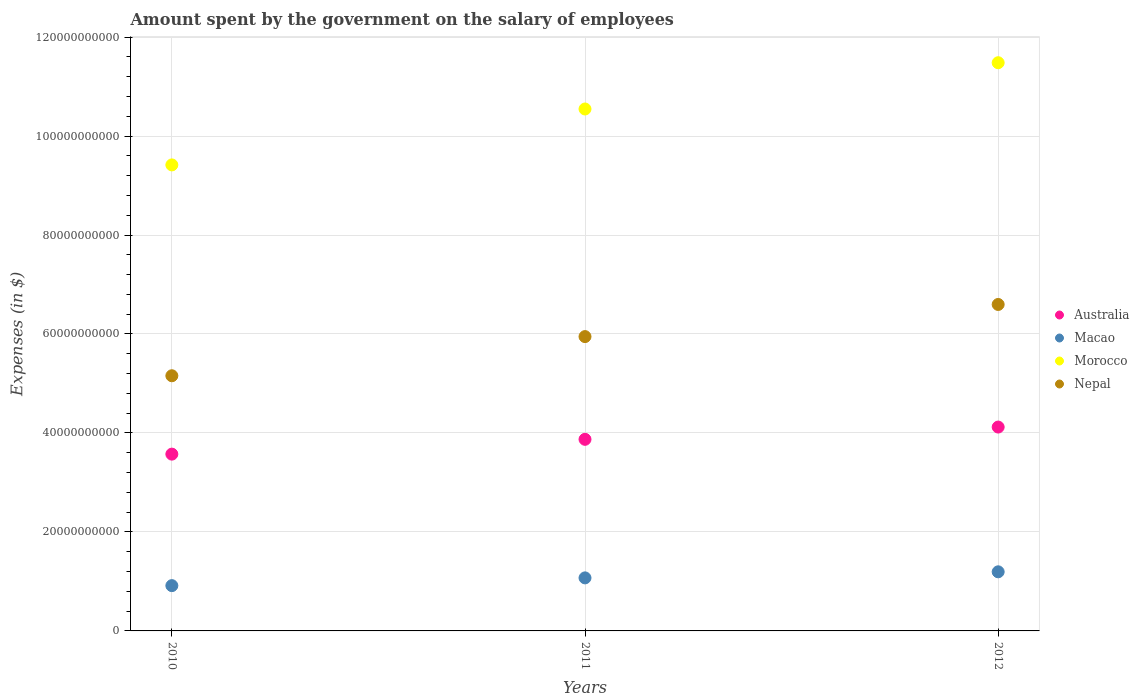What is the amount spent on the salary of employees by the government in Australia in 2011?
Give a very brief answer. 3.87e+1. Across all years, what is the maximum amount spent on the salary of employees by the government in Morocco?
Provide a succinct answer. 1.15e+11. Across all years, what is the minimum amount spent on the salary of employees by the government in Australia?
Provide a succinct answer. 3.57e+1. In which year was the amount spent on the salary of employees by the government in Macao maximum?
Your answer should be compact. 2012. In which year was the amount spent on the salary of employees by the government in Nepal minimum?
Offer a terse response. 2010. What is the total amount spent on the salary of employees by the government in Australia in the graph?
Provide a succinct answer. 1.16e+11. What is the difference between the amount spent on the salary of employees by the government in Australia in 2010 and that in 2012?
Your answer should be compact. -5.47e+09. What is the difference between the amount spent on the salary of employees by the government in Macao in 2011 and the amount spent on the salary of employees by the government in Australia in 2012?
Offer a terse response. -3.05e+1. What is the average amount spent on the salary of employees by the government in Australia per year?
Your answer should be compact. 3.85e+1. In the year 2011, what is the difference between the amount spent on the salary of employees by the government in Morocco and amount spent on the salary of employees by the government in Australia?
Offer a terse response. 6.67e+1. What is the ratio of the amount spent on the salary of employees by the government in Macao in 2010 to that in 2011?
Your response must be concise. 0.85. Is the amount spent on the salary of employees by the government in Macao in 2010 less than that in 2011?
Give a very brief answer. Yes. Is the difference between the amount spent on the salary of employees by the government in Morocco in 2010 and 2011 greater than the difference between the amount spent on the salary of employees by the government in Australia in 2010 and 2011?
Make the answer very short. No. What is the difference between the highest and the second highest amount spent on the salary of employees by the government in Australia?
Give a very brief answer. 2.48e+09. What is the difference between the highest and the lowest amount spent on the salary of employees by the government in Macao?
Your response must be concise. 2.79e+09. In how many years, is the amount spent on the salary of employees by the government in Nepal greater than the average amount spent on the salary of employees by the government in Nepal taken over all years?
Ensure brevity in your answer.  2. Is the sum of the amount spent on the salary of employees by the government in Morocco in 2011 and 2012 greater than the maximum amount spent on the salary of employees by the government in Australia across all years?
Provide a short and direct response. Yes. Is it the case that in every year, the sum of the amount spent on the salary of employees by the government in Nepal and amount spent on the salary of employees by the government in Australia  is greater than the amount spent on the salary of employees by the government in Macao?
Offer a terse response. Yes. Is the amount spent on the salary of employees by the government in Nepal strictly less than the amount spent on the salary of employees by the government in Macao over the years?
Provide a succinct answer. No. How many dotlines are there?
Provide a succinct answer. 4. How many years are there in the graph?
Make the answer very short. 3. What is the difference between two consecutive major ticks on the Y-axis?
Your answer should be compact. 2.00e+1. Are the values on the major ticks of Y-axis written in scientific E-notation?
Your answer should be very brief. No. Does the graph contain any zero values?
Give a very brief answer. No. Does the graph contain grids?
Give a very brief answer. Yes. Where does the legend appear in the graph?
Provide a short and direct response. Center right. How many legend labels are there?
Give a very brief answer. 4. What is the title of the graph?
Your answer should be very brief. Amount spent by the government on the salary of employees. What is the label or title of the X-axis?
Give a very brief answer. Years. What is the label or title of the Y-axis?
Your answer should be very brief. Expenses (in $). What is the Expenses (in $) of Australia in 2010?
Offer a very short reply. 3.57e+1. What is the Expenses (in $) of Macao in 2010?
Provide a short and direct response. 9.15e+09. What is the Expenses (in $) in Morocco in 2010?
Ensure brevity in your answer.  9.42e+1. What is the Expenses (in $) in Nepal in 2010?
Provide a succinct answer. 5.16e+1. What is the Expenses (in $) of Australia in 2011?
Provide a short and direct response. 3.87e+1. What is the Expenses (in $) of Macao in 2011?
Give a very brief answer. 1.07e+1. What is the Expenses (in $) of Morocco in 2011?
Keep it short and to the point. 1.05e+11. What is the Expenses (in $) in Nepal in 2011?
Keep it short and to the point. 5.95e+1. What is the Expenses (in $) of Australia in 2012?
Offer a terse response. 4.12e+1. What is the Expenses (in $) in Macao in 2012?
Give a very brief answer. 1.19e+1. What is the Expenses (in $) of Morocco in 2012?
Ensure brevity in your answer.  1.15e+11. What is the Expenses (in $) of Nepal in 2012?
Your answer should be very brief. 6.60e+1. Across all years, what is the maximum Expenses (in $) of Australia?
Provide a short and direct response. 4.12e+1. Across all years, what is the maximum Expenses (in $) of Macao?
Keep it short and to the point. 1.19e+1. Across all years, what is the maximum Expenses (in $) of Morocco?
Offer a terse response. 1.15e+11. Across all years, what is the maximum Expenses (in $) of Nepal?
Your response must be concise. 6.60e+1. Across all years, what is the minimum Expenses (in $) in Australia?
Your answer should be very brief. 3.57e+1. Across all years, what is the minimum Expenses (in $) of Macao?
Give a very brief answer. 9.15e+09. Across all years, what is the minimum Expenses (in $) of Morocco?
Provide a short and direct response. 9.42e+1. Across all years, what is the minimum Expenses (in $) in Nepal?
Provide a short and direct response. 5.16e+1. What is the total Expenses (in $) in Australia in the graph?
Provide a succinct answer. 1.16e+11. What is the total Expenses (in $) of Macao in the graph?
Your answer should be compact. 3.18e+1. What is the total Expenses (in $) of Morocco in the graph?
Your response must be concise. 3.14e+11. What is the total Expenses (in $) in Nepal in the graph?
Your answer should be very brief. 1.77e+11. What is the difference between the Expenses (in $) in Australia in 2010 and that in 2011?
Offer a very short reply. -2.99e+09. What is the difference between the Expenses (in $) in Macao in 2010 and that in 2011?
Offer a very short reply. -1.57e+09. What is the difference between the Expenses (in $) of Morocco in 2010 and that in 2011?
Your answer should be compact. -1.13e+1. What is the difference between the Expenses (in $) of Nepal in 2010 and that in 2011?
Your answer should be compact. -7.91e+09. What is the difference between the Expenses (in $) of Australia in 2010 and that in 2012?
Make the answer very short. -5.47e+09. What is the difference between the Expenses (in $) of Macao in 2010 and that in 2012?
Make the answer very short. -2.79e+09. What is the difference between the Expenses (in $) of Morocco in 2010 and that in 2012?
Keep it short and to the point. -2.06e+1. What is the difference between the Expenses (in $) in Nepal in 2010 and that in 2012?
Make the answer very short. -1.44e+1. What is the difference between the Expenses (in $) of Australia in 2011 and that in 2012?
Your answer should be compact. -2.48e+09. What is the difference between the Expenses (in $) of Macao in 2011 and that in 2012?
Your answer should be compact. -1.23e+09. What is the difference between the Expenses (in $) in Morocco in 2011 and that in 2012?
Give a very brief answer. -9.35e+09. What is the difference between the Expenses (in $) in Nepal in 2011 and that in 2012?
Provide a short and direct response. -6.49e+09. What is the difference between the Expenses (in $) of Australia in 2010 and the Expenses (in $) of Macao in 2011?
Your answer should be very brief. 2.50e+1. What is the difference between the Expenses (in $) of Australia in 2010 and the Expenses (in $) of Morocco in 2011?
Ensure brevity in your answer.  -6.97e+1. What is the difference between the Expenses (in $) in Australia in 2010 and the Expenses (in $) in Nepal in 2011?
Your response must be concise. -2.37e+1. What is the difference between the Expenses (in $) in Macao in 2010 and the Expenses (in $) in Morocco in 2011?
Offer a terse response. -9.63e+1. What is the difference between the Expenses (in $) of Macao in 2010 and the Expenses (in $) of Nepal in 2011?
Provide a succinct answer. -5.03e+1. What is the difference between the Expenses (in $) of Morocco in 2010 and the Expenses (in $) of Nepal in 2011?
Your response must be concise. 3.47e+1. What is the difference between the Expenses (in $) in Australia in 2010 and the Expenses (in $) in Macao in 2012?
Make the answer very short. 2.38e+1. What is the difference between the Expenses (in $) in Australia in 2010 and the Expenses (in $) in Morocco in 2012?
Make the answer very short. -7.91e+1. What is the difference between the Expenses (in $) in Australia in 2010 and the Expenses (in $) in Nepal in 2012?
Give a very brief answer. -3.02e+1. What is the difference between the Expenses (in $) in Macao in 2010 and the Expenses (in $) in Morocco in 2012?
Ensure brevity in your answer.  -1.06e+11. What is the difference between the Expenses (in $) in Macao in 2010 and the Expenses (in $) in Nepal in 2012?
Your response must be concise. -5.68e+1. What is the difference between the Expenses (in $) of Morocco in 2010 and the Expenses (in $) of Nepal in 2012?
Offer a terse response. 2.82e+1. What is the difference between the Expenses (in $) in Australia in 2011 and the Expenses (in $) in Macao in 2012?
Make the answer very short. 2.68e+1. What is the difference between the Expenses (in $) in Australia in 2011 and the Expenses (in $) in Morocco in 2012?
Keep it short and to the point. -7.61e+1. What is the difference between the Expenses (in $) in Australia in 2011 and the Expenses (in $) in Nepal in 2012?
Ensure brevity in your answer.  -2.73e+1. What is the difference between the Expenses (in $) in Macao in 2011 and the Expenses (in $) in Morocco in 2012?
Your response must be concise. -1.04e+11. What is the difference between the Expenses (in $) of Macao in 2011 and the Expenses (in $) of Nepal in 2012?
Your answer should be very brief. -5.52e+1. What is the difference between the Expenses (in $) of Morocco in 2011 and the Expenses (in $) of Nepal in 2012?
Ensure brevity in your answer.  3.95e+1. What is the average Expenses (in $) in Australia per year?
Provide a succinct answer. 3.85e+1. What is the average Expenses (in $) in Macao per year?
Provide a short and direct response. 1.06e+1. What is the average Expenses (in $) in Morocco per year?
Provide a short and direct response. 1.05e+11. What is the average Expenses (in $) in Nepal per year?
Ensure brevity in your answer.  5.90e+1. In the year 2010, what is the difference between the Expenses (in $) in Australia and Expenses (in $) in Macao?
Ensure brevity in your answer.  2.66e+1. In the year 2010, what is the difference between the Expenses (in $) in Australia and Expenses (in $) in Morocco?
Ensure brevity in your answer.  -5.84e+1. In the year 2010, what is the difference between the Expenses (in $) in Australia and Expenses (in $) in Nepal?
Ensure brevity in your answer.  -1.58e+1. In the year 2010, what is the difference between the Expenses (in $) in Macao and Expenses (in $) in Morocco?
Your answer should be very brief. -8.50e+1. In the year 2010, what is the difference between the Expenses (in $) in Macao and Expenses (in $) in Nepal?
Offer a terse response. -4.24e+1. In the year 2010, what is the difference between the Expenses (in $) of Morocco and Expenses (in $) of Nepal?
Ensure brevity in your answer.  4.26e+1. In the year 2011, what is the difference between the Expenses (in $) in Australia and Expenses (in $) in Macao?
Give a very brief answer. 2.80e+1. In the year 2011, what is the difference between the Expenses (in $) in Australia and Expenses (in $) in Morocco?
Offer a terse response. -6.67e+1. In the year 2011, what is the difference between the Expenses (in $) of Australia and Expenses (in $) of Nepal?
Provide a succinct answer. -2.08e+1. In the year 2011, what is the difference between the Expenses (in $) of Macao and Expenses (in $) of Morocco?
Give a very brief answer. -9.47e+1. In the year 2011, what is the difference between the Expenses (in $) of Macao and Expenses (in $) of Nepal?
Provide a short and direct response. -4.88e+1. In the year 2011, what is the difference between the Expenses (in $) in Morocco and Expenses (in $) in Nepal?
Provide a short and direct response. 4.60e+1. In the year 2012, what is the difference between the Expenses (in $) of Australia and Expenses (in $) of Macao?
Your answer should be very brief. 2.92e+1. In the year 2012, what is the difference between the Expenses (in $) in Australia and Expenses (in $) in Morocco?
Provide a succinct answer. -7.36e+1. In the year 2012, what is the difference between the Expenses (in $) in Australia and Expenses (in $) in Nepal?
Give a very brief answer. -2.48e+1. In the year 2012, what is the difference between the Expenses (in $) in Macao and Expenses (in $) in Morocco?
Give a very brief answer. -1.03e+11. In the year 2012, what is the difference between the Expenses (in $) of Macao and Expenses (in $) of Nepal?
Provide a short and direct response. -5.40e+1. In the year 2012, what is the difference between the Expenses (in $) of Morocco and Expenses (in $) of Nepal?
Offer a very short reply. 4.88e+1. What is the ratio of the Expenses (in $) of Australia in 2010 to that in 2011?
Offer a terse response. 0.92. What is the ratio of the Expenses (in $) in Macao in 2010 to that in 2011?
Offer a very short reply. 0.85. What is the ratio of the Expenses (in $) of Morocco in 2010 to that in 2011?
Offer a terse response. 0.89. What is the ratio of the Expenses (in $) of Nepal in 2010 to that in 2011?
Give a very brief answer. 0.87. What is the ratio of the Expenses (in $) of Australia in 2010 to that in 2012?
Offer a terse response. 0.87. What is the ratio of the Expenses (in $) in Macao in 2010 to that in 2012?
Give a very brief answer. 0.77. What is the ratio of the Expenses (in $) in Morocco in 2010 to that in 2012?
Ensure brevity in your answer.  0.82. What is the ratio of the Expenses (in $) in Nepal in 2010 to that in 2012?
Provide a succinct answer. 0.78. What is the ratio of the Expenses (in $) of Australia in 2011 to that in 2012?
Keep it short and to the point. 0.94. What is the ratio of the Expenses (in $) in Macao in 2011 to that in 2012?
Keep it short and to the point. 0.9. What is the ratio of the Expenses (in $) of Morocco in 2011 to that in 2012?
Give a very brief answer. 0.92. What is the ratio of the Expenses (in $) in Nepal in 2011 to that in 2012?
Give a very brief answer. 0.9. What is the difference between the highest and the second highest Expenses (in $) in Australia?
Offer a terse response. 2.48e+09. What is the difference between the highest and the second highest Expenses (in $) in Macao?
Ensure brevity in your answer.  1.23e+09. What is the difference between the highest and the second highest Expenses (in $) in Morocco?
Provide a short and direct response. 9.35e+09. What is the difference between the highest and the second highest Expenses (in $) in Nepal?
Offer a very short reply. 6.49e+09. What is the difference between the highest and the lowest Expenses (in $) in Australia?
Keep it short and to the point. 5.47e+09. What is the difference between the highest and the lowest Expenses (in $) of Macao?
Your answer should be very brief. 2.79e+09. What is the difference between the highest and the lowest Expenses (in $) in Morocco?
Offer a very short reply. 2.06e+1. What is the difference between the highest and the lowest Expenses (in $) of Nepal?
Provide a short and direct response. 1.44e+1. 